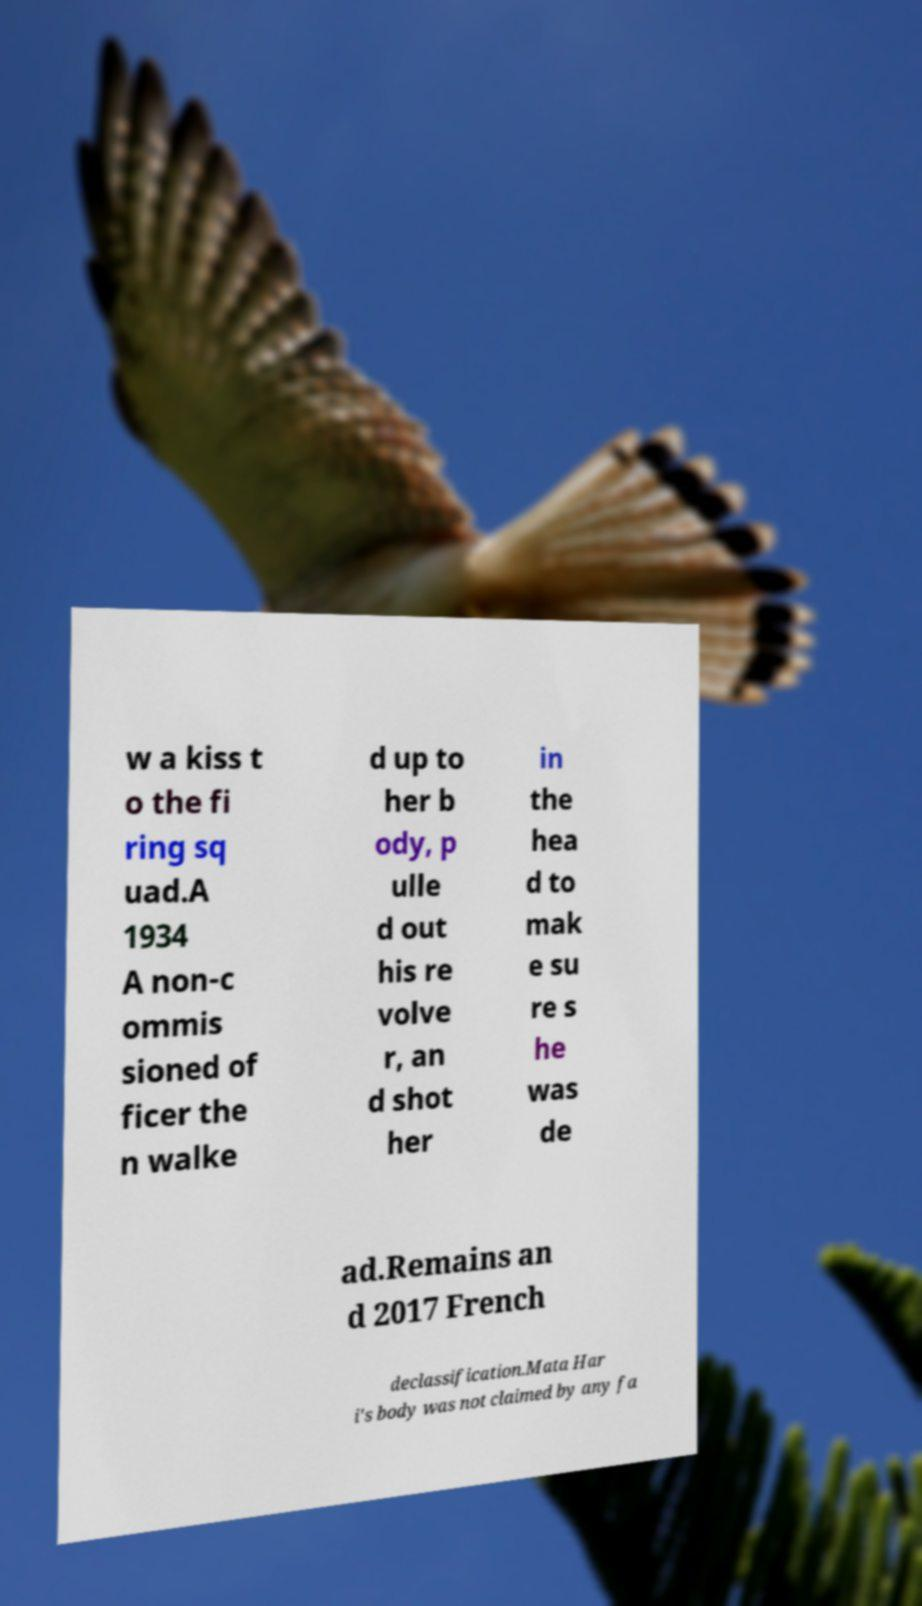I need the written content from this picture converted into text. Can you do that? w a kiss t o the fi ring sq uad.A 1934 A non-c ommis sioned of ficer the n walke d up to her b ody, p ulle d out his re volve r, an d shot her in the hea d to mak e su re s he was de ad.Remains an d 2017 French declassification.Mata Har i's body was not claimed by any fa 